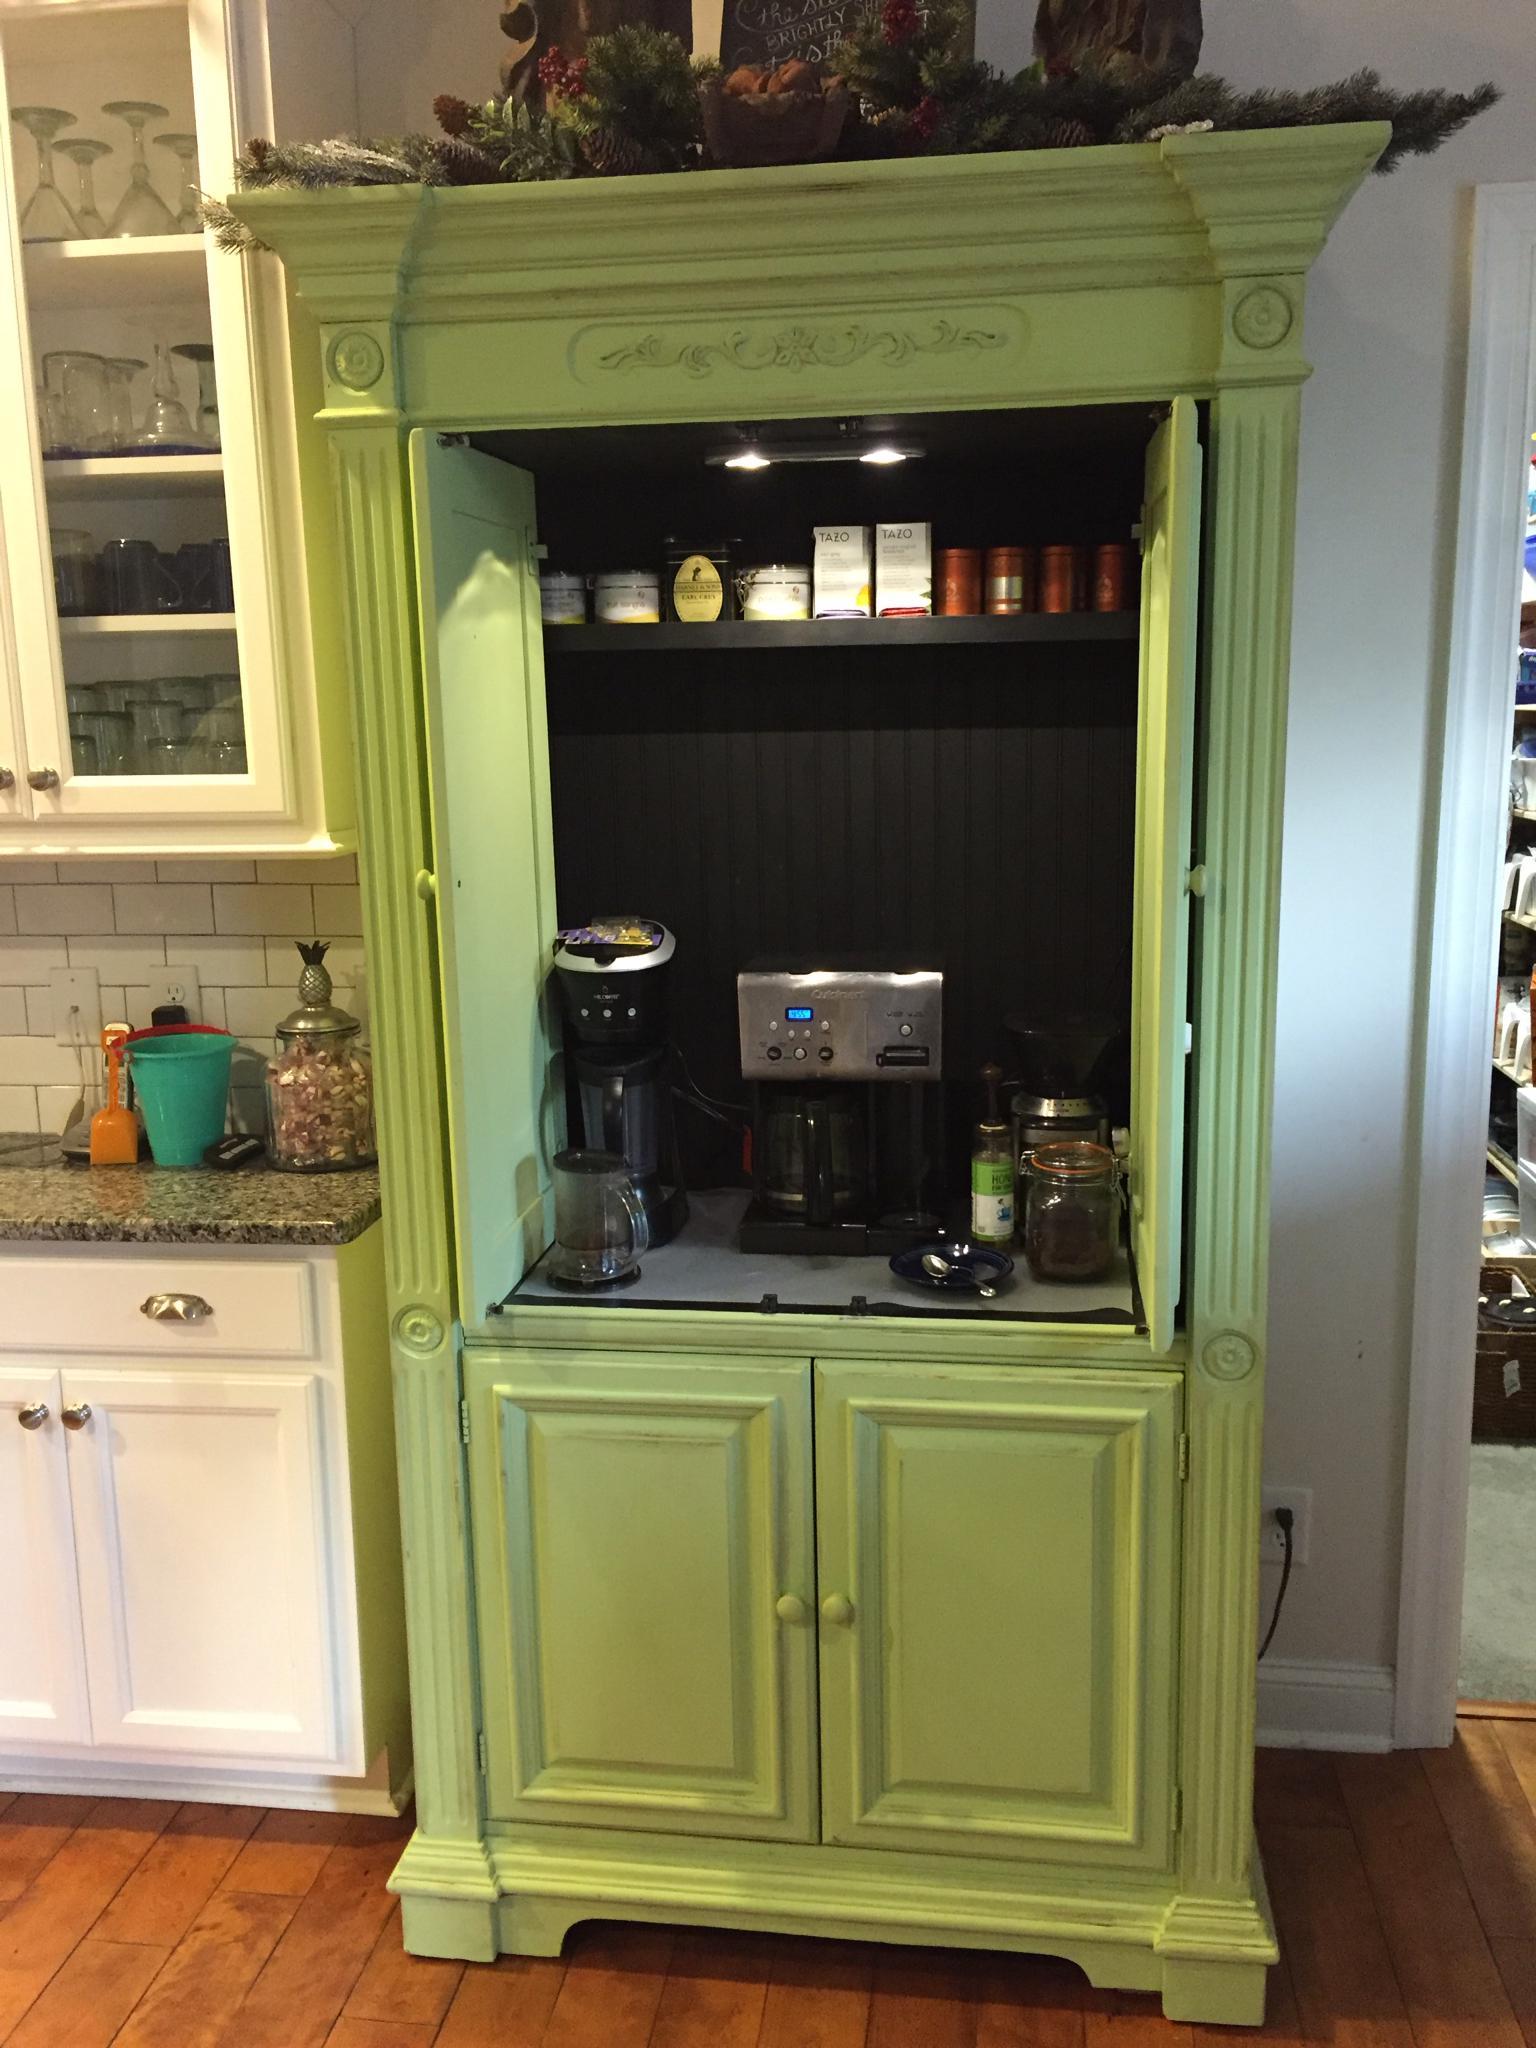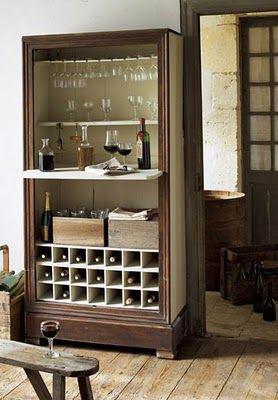The first image is the image on the left, the second image is the image on the right. Given the left and right images, does the statement "A wooden painted hutch has a bottom door open that shows an X shaped space for storing bottles of wine, and glasses hanging upside down in the upper section." hold true? Answer yes or no. No. The first image is the image on the left, the second image is the image on the right. Analyze the images presented: Is the assertion "A brown cabinet is used for storage in the image on the right." valid? Answer yes or no. Yes. 